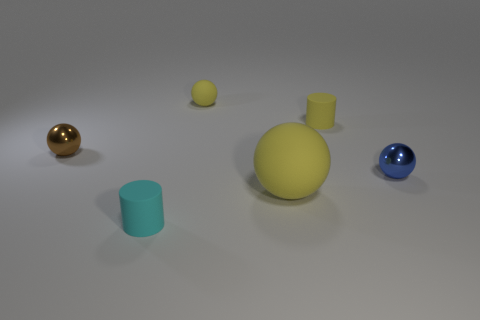There is a cylinder that is the same color as the large thing; what is its size?
Your response must be concise. Small. What color is the big matte thing?
Your answer should be very brief. Yellow. Is the color of the big thing the same as the tiny rubber cylinder that is behind the tiny blue ball?
Your answer should be very brief. Yes. Do the yellow object in front of the brown shiny object and the tiny blue metal thing have the same shape?
Provide a short and direct response. Yes. What shape is the tiny yellow thing that is on the left side of the yellow rubber sphere right of the yellow matte thing that is to the left of the large rubber object?
Provide a succinct answer. Sphere. There is a big matte thing that is the same color as the tiny rubber ball; what is its shape?
Offer a very short reply. Sphere. There is a thing that is left of the small yellow ball and in front of the tiny blue shiny ball; what is it made of?
Make the answer very short. Rubber. Are there fewer things than small balls?
Offer a very short reply. No. Does the cyan thing have the same shape as the tiny yellow matte object that is in front of the small yellow rubber sphere?
Give a very brief answer. Yes. There is a cylinder that is behind the blue metal thing; does it have the same size as the large matte object?
Your response must be concise. No. 